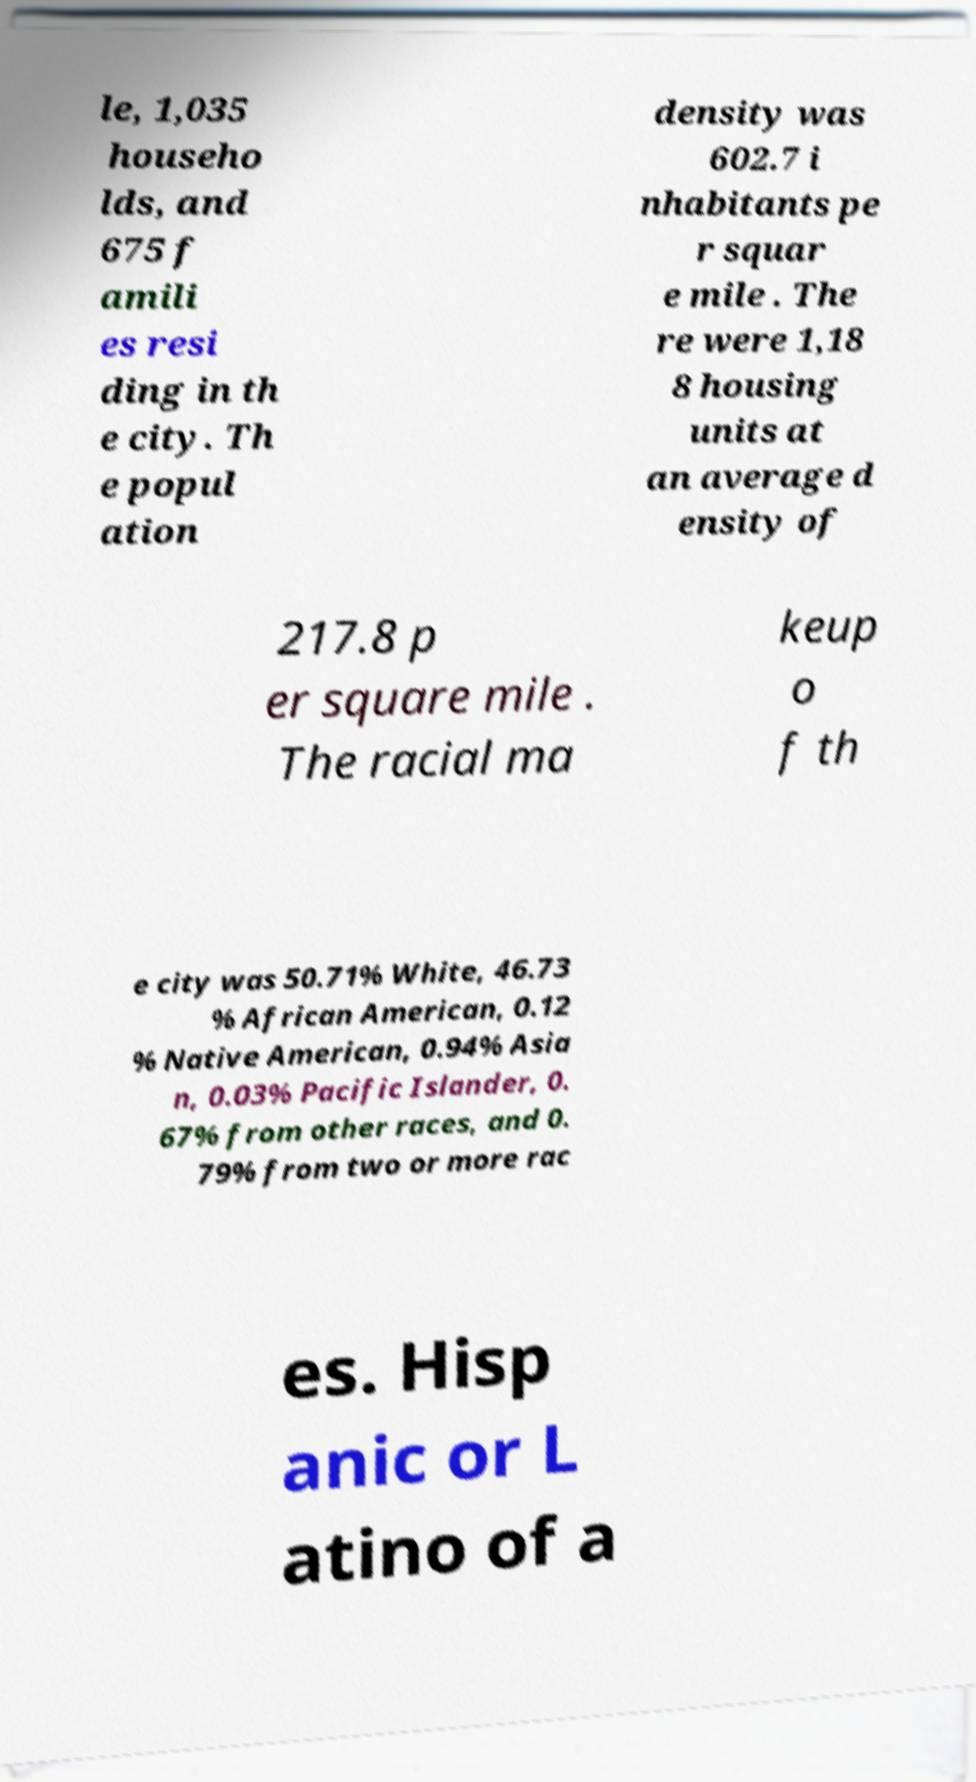For documentation purposes, I need the text within this image transcribed. Could you provide that? le, 1,035 househo lds, and 675 f amili es resi ding in th e city. Th e popul ation density was 602.7 i nhabitants pe r squar e mile . The re were 1,18 8 housing units at an average d ensity of 217.8 p er square mile . The racial ma keup o f th e city was 50.71% White, 46.73 % African American, 0.12 % Native American, 0.94% Asia n, 0.03% Pacific Islander, 0. 67% from other races, and 0. 79% from two or more rac es. Hisp anic or L atino of a 